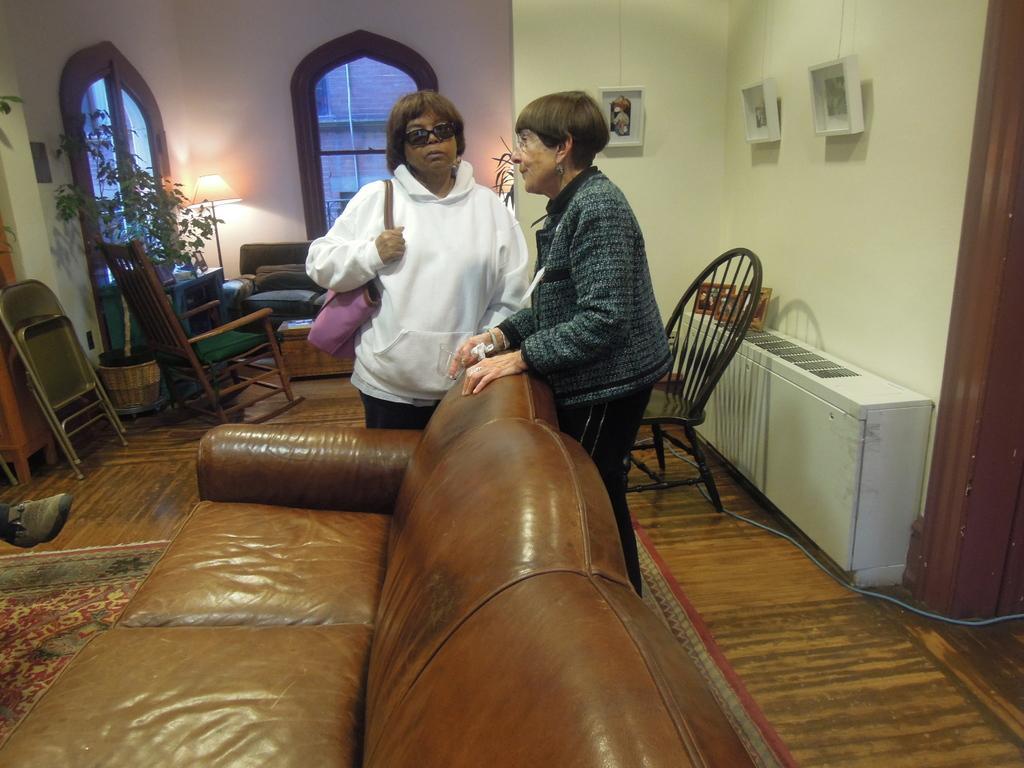Describe this image in one or two sentences. In this image I see 2 women who are near the sofa and this woman is holding a bag. I can also see these 2 are standing. In the background I see the chairs, windows, plant and the wall. 